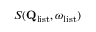<formula> <loc_0><loc_0><loc_500><loc_500>S ( Q _ { l i s t } , \omega _ { l i s t } )</formula> 